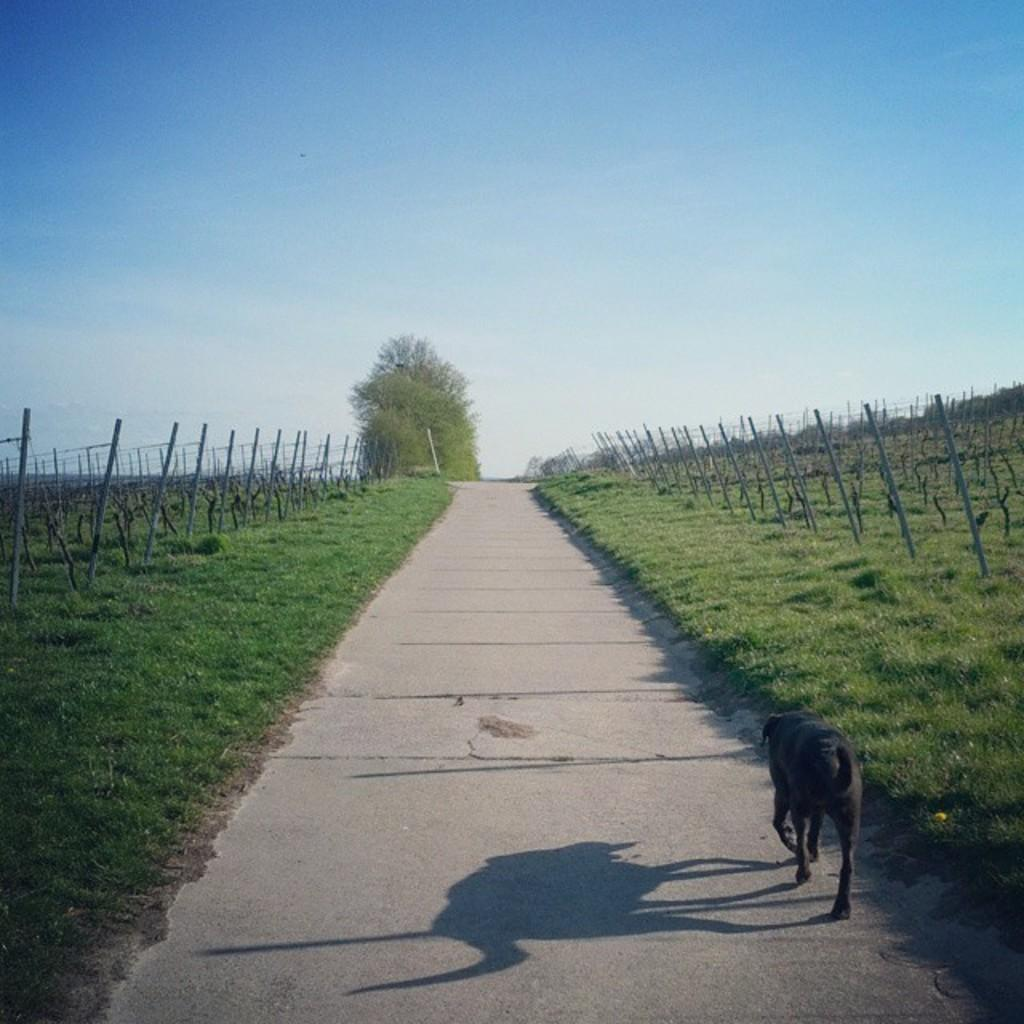What type of animal is in the image? There is a dog in the image. What is the dog doing in the image? The dog is walking. What can be seen on both sides of the image? There are fences on the left and right sides of the image. What type of vegetation is present in the image? There is grass in the image. What is visible in the background of the image? There are trees and the sky in the background of the image. What is the condition of the sky in the image? The sky is visible in the background of the image, and there are clouds present. What type of nut is the dog holding in its mouth in the image? There is no nut present in the image; the dog is simply walking. Is the ground covered in snow in the image? No, the ground is covered in grass, not snow. 